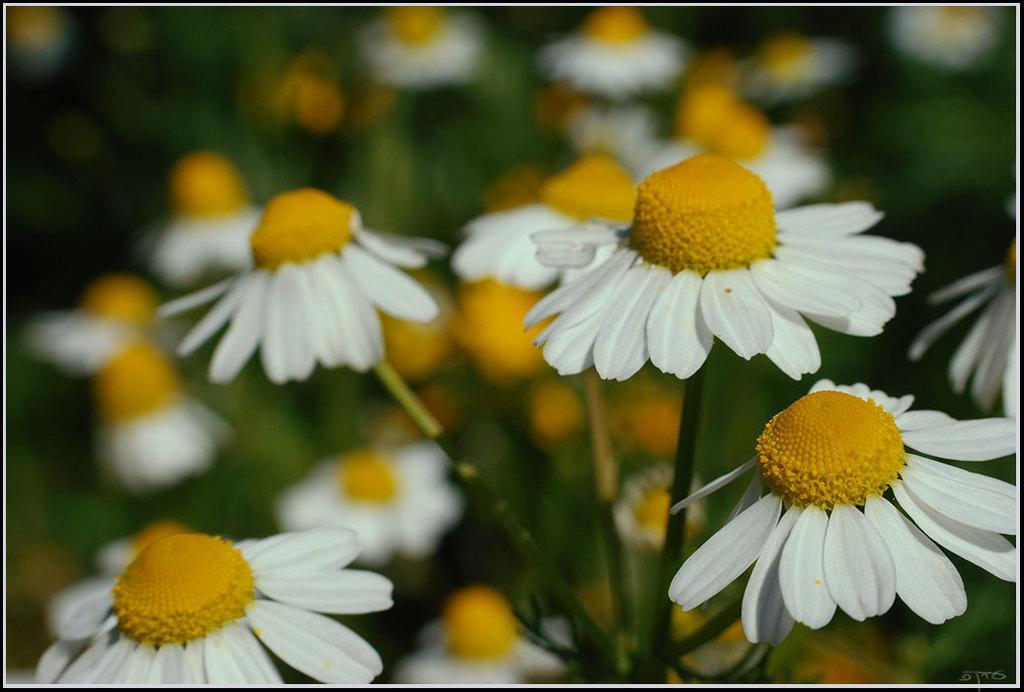Describe this image in one or two sentences. There are white color sunflowers of the plants. And the background is blurred. 